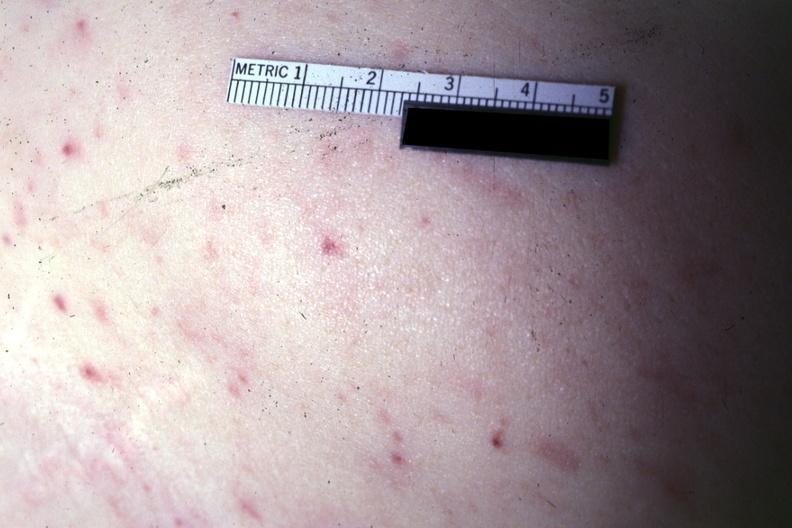s this typical thecoma with yellow foci present?
Answer the question using a single word or phrase. No 